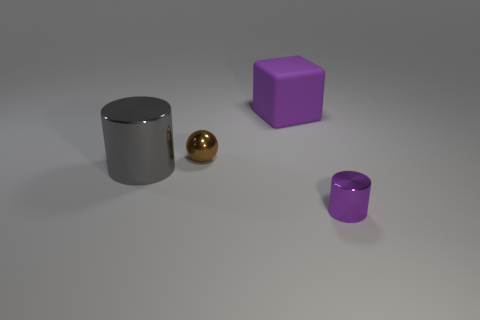Add 2 small brown matte cubes. How many objects exist? 6 Add 1 large cyan matte objects. How many large cyan matte objects exist? 1 Subtract 0 red spheres. How many objects are left? 4 Subtract all large purple matte blocks. Subtract all small metallic spheres. How many objects are left? 2 Add 1 brown spheres. How many brown spheres are left? 2 